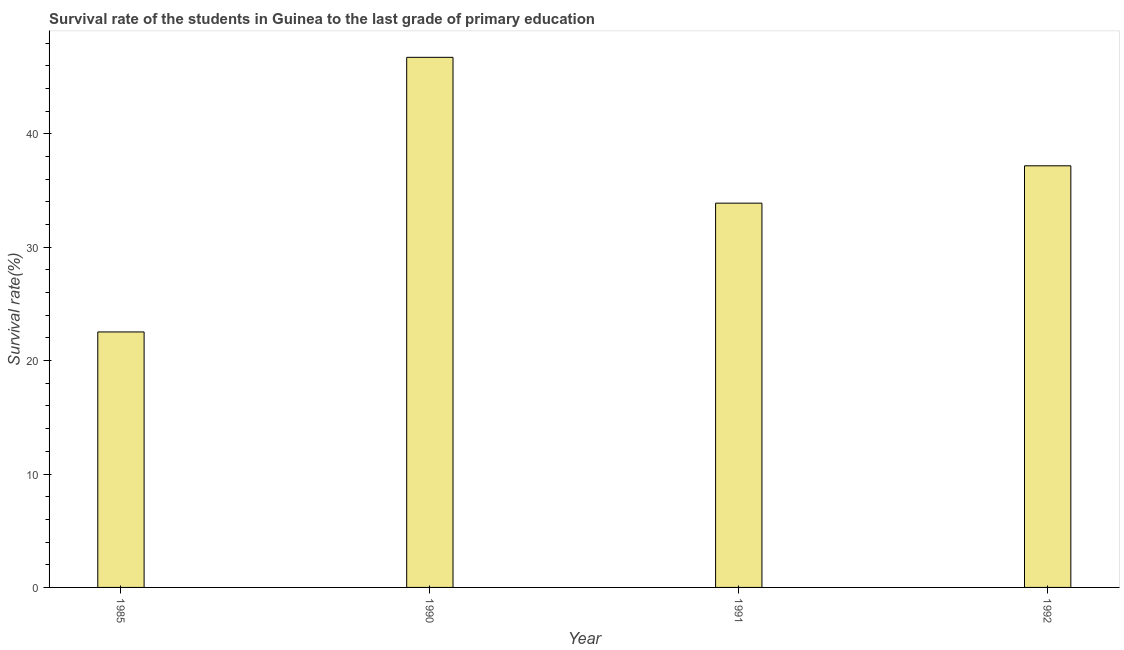What is the title of the graph?
Keep it short and to the point. Survival rate of the students in Guinea to the last grade of primary education. What is the label or title of the X-axis?
Make the answer very short. Year. What is the label or title of the Y-axis?
Provide a succinct answer. Survival rate(%). What is the survival rate in primary education in 1990?
Your answer should be compact. 46.75. Across all years, what is the maximum survival rate in primary education?
Your answer should be very brief. 46.75. Across all years, what is the minimum survival rate in primary education?
Offer a terse response. 22.53. In which year was the survival rate in primary education minimum?
Make the answer very short. 1985. What is the sum of the survival rate in primary education?
Offer a terse response. 140.34. What is the difference between the survival rate in primary education in 1990 and 1992?
Offer a very short reply. 9.57. What is the average survival rate in primary education per year?
Provide a short and direct response. 35.09. What is the median survival rate in primary education?
Offer a very short reply. 35.53. In how many years, is the survival rate in primary education greater than 18 %?
Your response must be concise. 4. Do a majority of the years between 1991 and 1992 (inclusive) have survival rate in primary education greater than 10 %?
Your response must be concise. Yes. What is the ratio of the survival rate in primary education in 1991 to that in 1992?
Ensure brevity in your answer.  0.91. Is the difference between the survival rate in primary education in 1985 and 1991 greater than the difference between any two years?
Give a very brief answer. No. What is the difference between the highest and the second highest survival rate in primary education?
Make the answer very short. 9.57. What is the difference between the highest and the lowest survival rate in primary education?
Your answer should be compact. 24.22. In how many years, is the survival rate in primary education greater than the average survival rate in primary education taken over all years?
Make the answer very short. 2. How many bars are there?
Make the answer very short. 4. What is the difference between two consecutive major ticks on the Y-axis?
Give a very brief answer. 10. Are the values on the major ticks of Y-axis written in scientific E-notation?
Your response must be concise. No. What is the Survival rate(%) in 1985?
Your answer should be very brief. 22.53. What is the Survival rate(%) of 1990?
Offer a very short reply. 46.75. What is the Survival rate(%) in 1991?
Your response must be concise. 33.89. What is the Survival rate(%) in 1992?
Provide a succinct answer. 37.18. What is the difference between the Survival rate(%) in 1985 and 1990?
Your answer should be very brief. -24.22. What is the difference between the Survival rate(%) in 1985 and 1991?
Provide a succinct answer. -11.36. What is the difference between the Survival rate(%) in 1985 and 1992?
Offer a very short reply. -14.65. What is the difference between the Survival rate(%) in 1990 and 1991?
Make the answer very short. 12.86. What is the difference between the Survival rate(%) in 1990 and 1992?
Your response must be concise. 9.57. What is the difference between the Survival rate(%) in 1991 and 1992?
Give a very brief answer. -3.29. What is the ratio of the Survival rate(%) in 1985 to that in 1990?
Provide a succinct answer. 0.48. What is the ratio of the Survival rate(%) in 1985 to that in 1991?
Your answer should be compact. 0.67. What is the ratio of the Survival rate(%) in 1985 to that in 1992?
Make the answer very short. 0.61. What is the ratio of the Survival rate(%) in 1990 to that in 1991?
Provide a succinct answer. 1.38. What is the ratio of the Survival rate(%) in 1990 to that in 1992?
Offer a terse response. 1.26. What is the ratio of the Survival rate(%) in 1991 to that in 1992?
Your answer should be very brief. 0.91. 